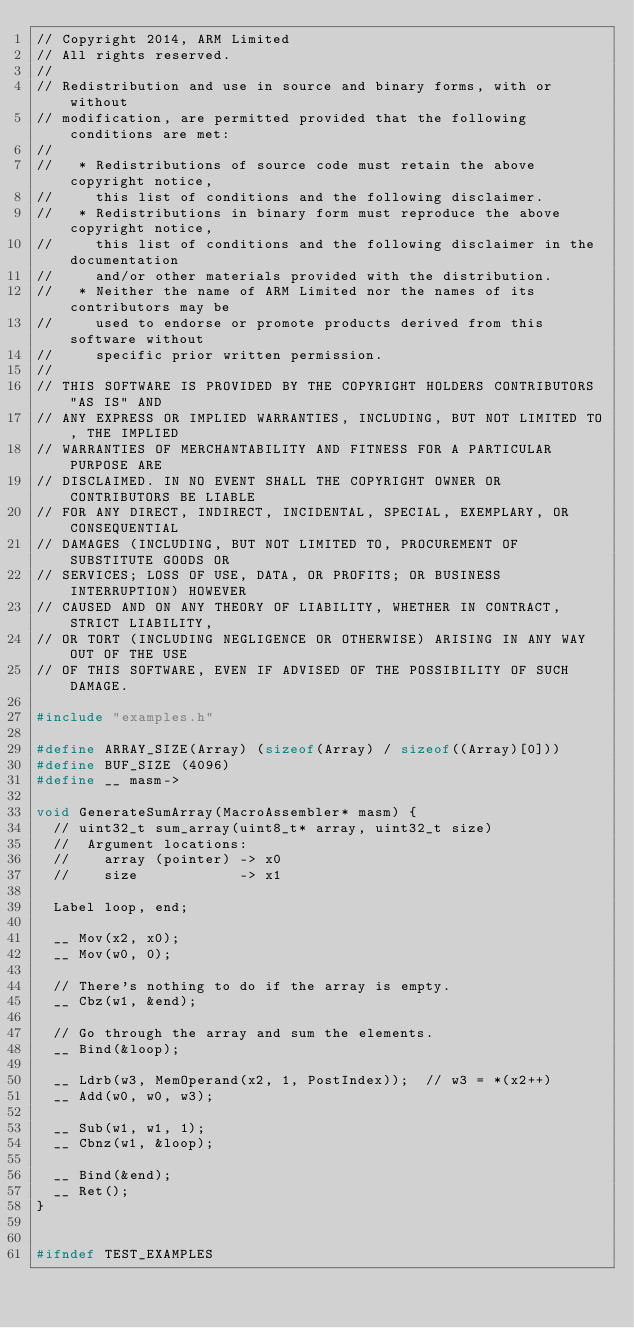<code> <loc_0><loc_0><loc_500><loc_500><_C++_>// Copyright 2014, ARM Limited
// All rights reserved.
//
// Redistribution and use in source and binary forms, with or without
// modification, are permitted provided that the following conditions are met:
//
//   * Redistributions of source code must retain the above copyright notice,
//     this list of conditions and the following disclaimer.
//   * Redistributions in binary form must reproduce the above copyright notice,
//     this list of conditions and the following disclaimer in the documentation
//     and/or other materials provided with the distribution.
//   * Neither the name of ARM Limited nor the names of its contributors may be
//     used to endorse or promote products derived from this software without
//     specific prior written permission.
//
// THIS SOFTWARE IS PROVIDED BY THE COPYRIGHT HOLDERS CONTRIBUTORS "AS IS" AND
// ANY EXPRESS OR IMPLIED WARRANTIES, INCLUDING, BUT NOT LIMITED TO, THE IMPLIED
// WARRANTIES OF MERCHANTABILITY AND FITNESS FOR A PARTICULAR PURPOSE ARE
// DISCLAIMED. IN NO EVENT SHALL THE COPYRIGHT OWNER OR CONTRIBUTORS BE LIABLE
// FOR ANY DIRECT, INDIRECT, INCIDENTAL, SPECIAL, EXEMPLARY, OR CONSEQUENTIAL
// DAMAGES (INCLUDING, BUT NOT LIMITED TO, PROCUREMENT OF SUBSTITUTE GOODS OR
// SERVICES; LOSS OF USE, DATA, OR PROFITS; OR BUSINESS INTERRUPTION) HOWEVER
// CAUSED AND ON ANY THEORY OF LIABILITY, WHETHER IN CONTRACT, STRICT LIABILITY,
// OR TORT (INCLUDING NEGLIGENCE OR OTHERWISE) ARISING IN ANY WAY OUT OF THE USE
// OF THIS SOFTWARE, EVEN IF ADVISED OF THE POSSIBILITY OF SUCH DAMAGE.

#include "examples.h"

#define ARRAY_SIZE(Array) (sizeof(Array) / sizeof((Array)[0]))
#define BUF_SIZE (4096)
#define __ masm->

void GenerateSumArray(MacroAssembler* masm) {
  // uint32_t sum_array(uint8_t* array, uint32_t size)
  //  Argument locations:
  //    array (pointer) -> x0
  //    size            -> x1

  Label loop, end;

  __ Mov(x2, x0);
  __ Mov(w0, 0);

  // There's nothing to do if the array is empty.
  __ Cbz(w1, &end);

  // Go through the array and sum the elements.
  __ Bind(&loop);

  __ Ldrb(w3, MemOperand(x2, 1, PostIndex));  // w3 = *(x2++)
  __ Add(w0, w0, w3);

  __ Sub(w1, w1, 1);
  __ Cbnz(w1, &loop);

  __ Bind(&end);
  __ Ret();
}


#ifndef TEST_EXAMPLES</code> 